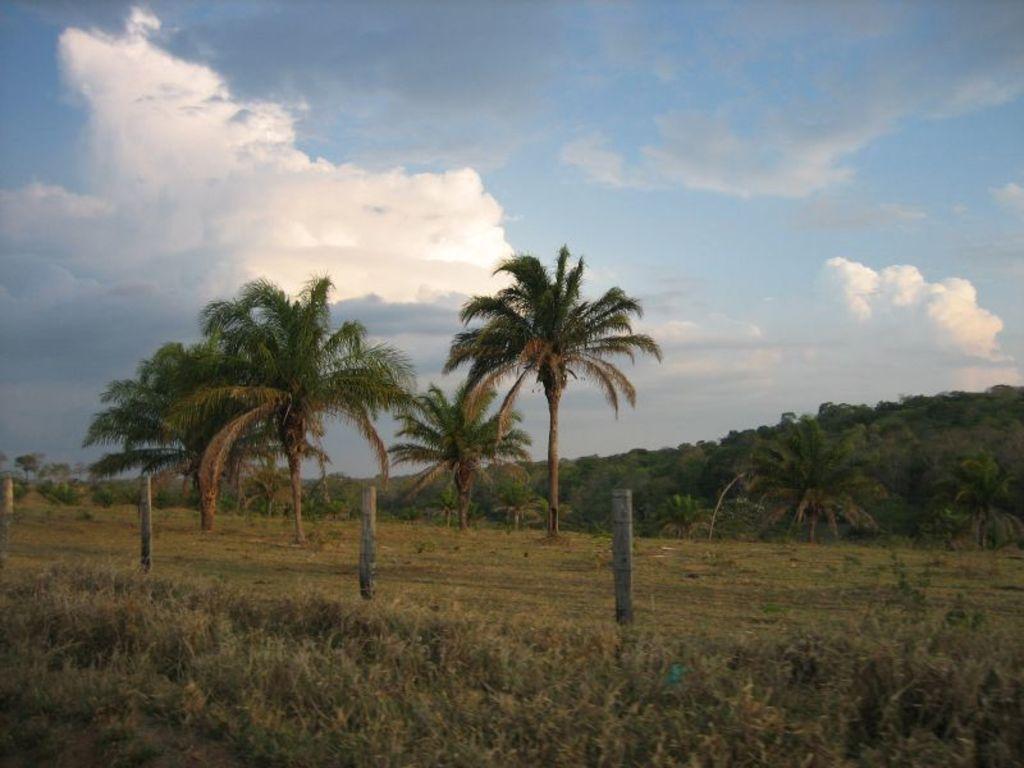In one or two sentences, can you explain what this image depicts? In the center of the image we can see the fence. In the background of the image we can see the trees, grass and ground. At the bottom of the image we can see the plants. At the top of the image we can see the clouds in the sky. 